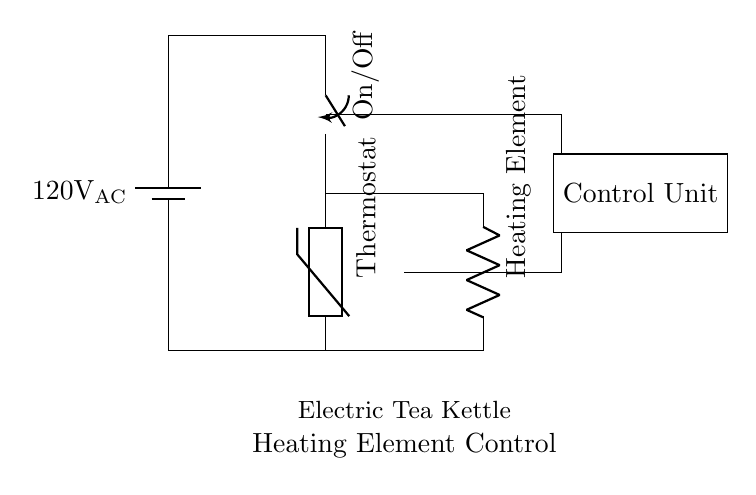What is the voltage of this circuit? The voltage is 120 volts, as indicated by the battery symbol labeled with the value 120V AC.
Answer: 120 volts What component controls the heating element? The component that controls the heating element is the thermostat, which is a thermistor in this circuit that regulates temperature by switching the heating element on or off.
Answer: Thermostat What does the switch control? The switch controls the power supply to the thermostat, allowing the user to turn the kettle on or off as needed for heating the water.
Answer: On/Off How many main components are there in this circuit? There are four main components: the battery (power supply), switch, thermostat (thermistor), and heating element (resistor).
Answer: Four What type of circuit is this? This is a control circuit used in electric appliances, specifically designed to manage the heating element of an electric tea kettle.
Answer: Control circuit What happens when the thermostat activates? When the thermostat activates, it closes the circuit, enabling current to flow through the heating element, which generates heat to warm the water.
Answer: Heating element activation Why is a thermistor used instead of a standard resistor? A thermistor is used because it responds to temperature changes, allowing for better control of the heating process by turning the element on or off at set temperatures, rather than providing a constant resistance.
Answer: Temperature control 